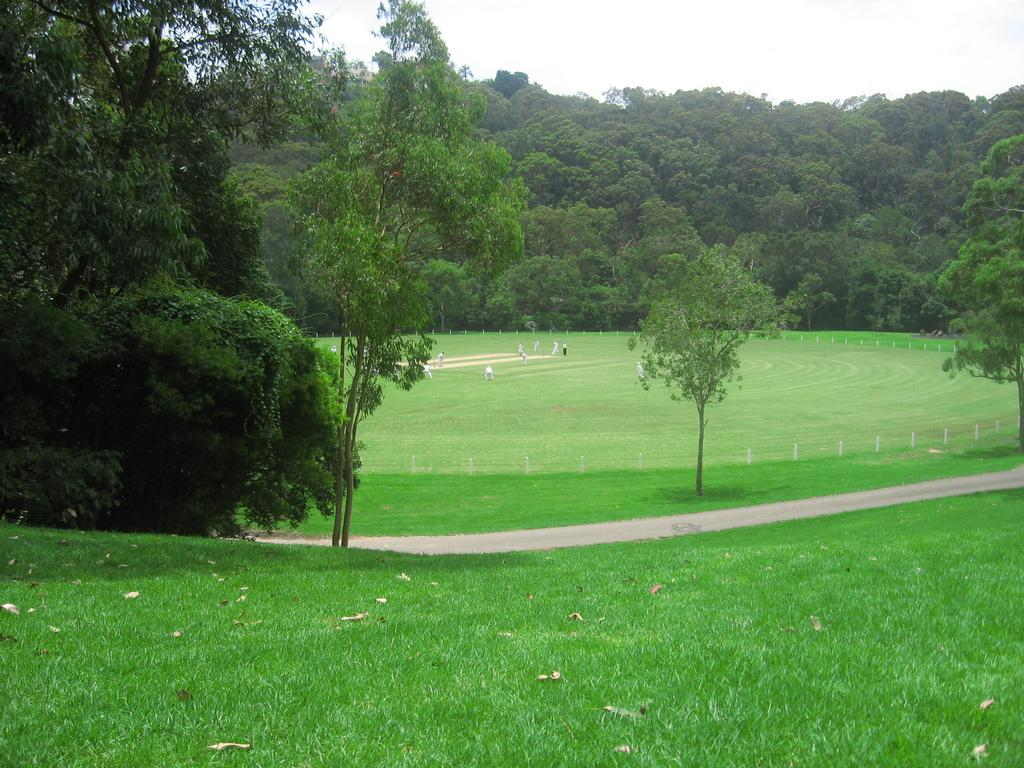What activity are the people engaged in at the location in the image? The people are playing in the playground. What can be seen in the background of the image? There are plants and trees in the background. How would you describe the weather based on the image? The sky is clear, suggesting good weather. What news headline is being discussed by the person in the image? There is no person in the image discussing a news headline; the image features people playing in a playground. What type of nose can be seen on the person in the image? There is no person in the image, so it is not possible to determine the type of nose they might have. 